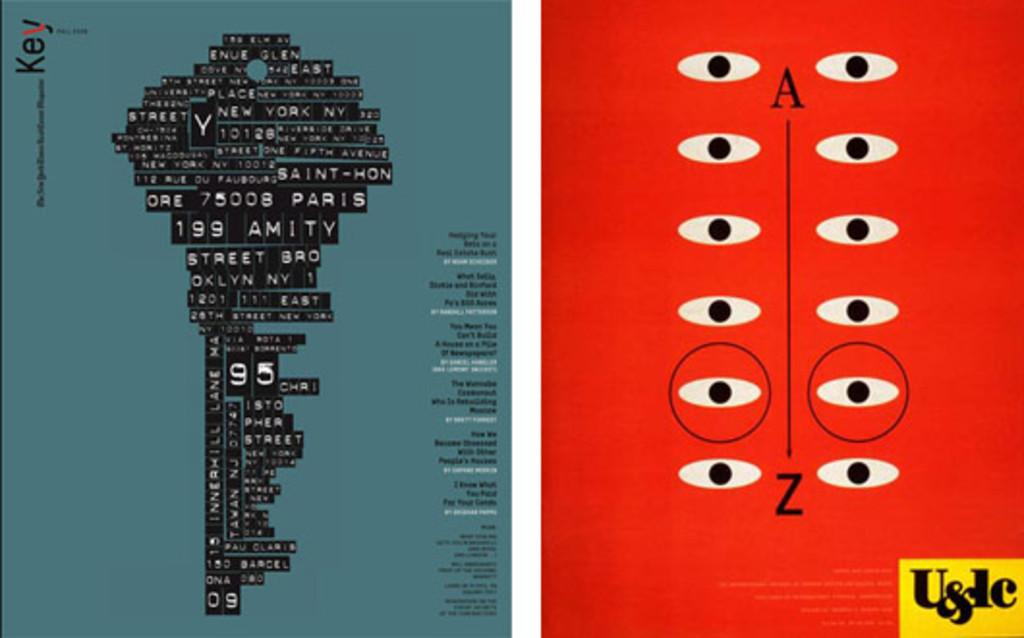What city is on the key?
Keep it short and to the point. Paris. 